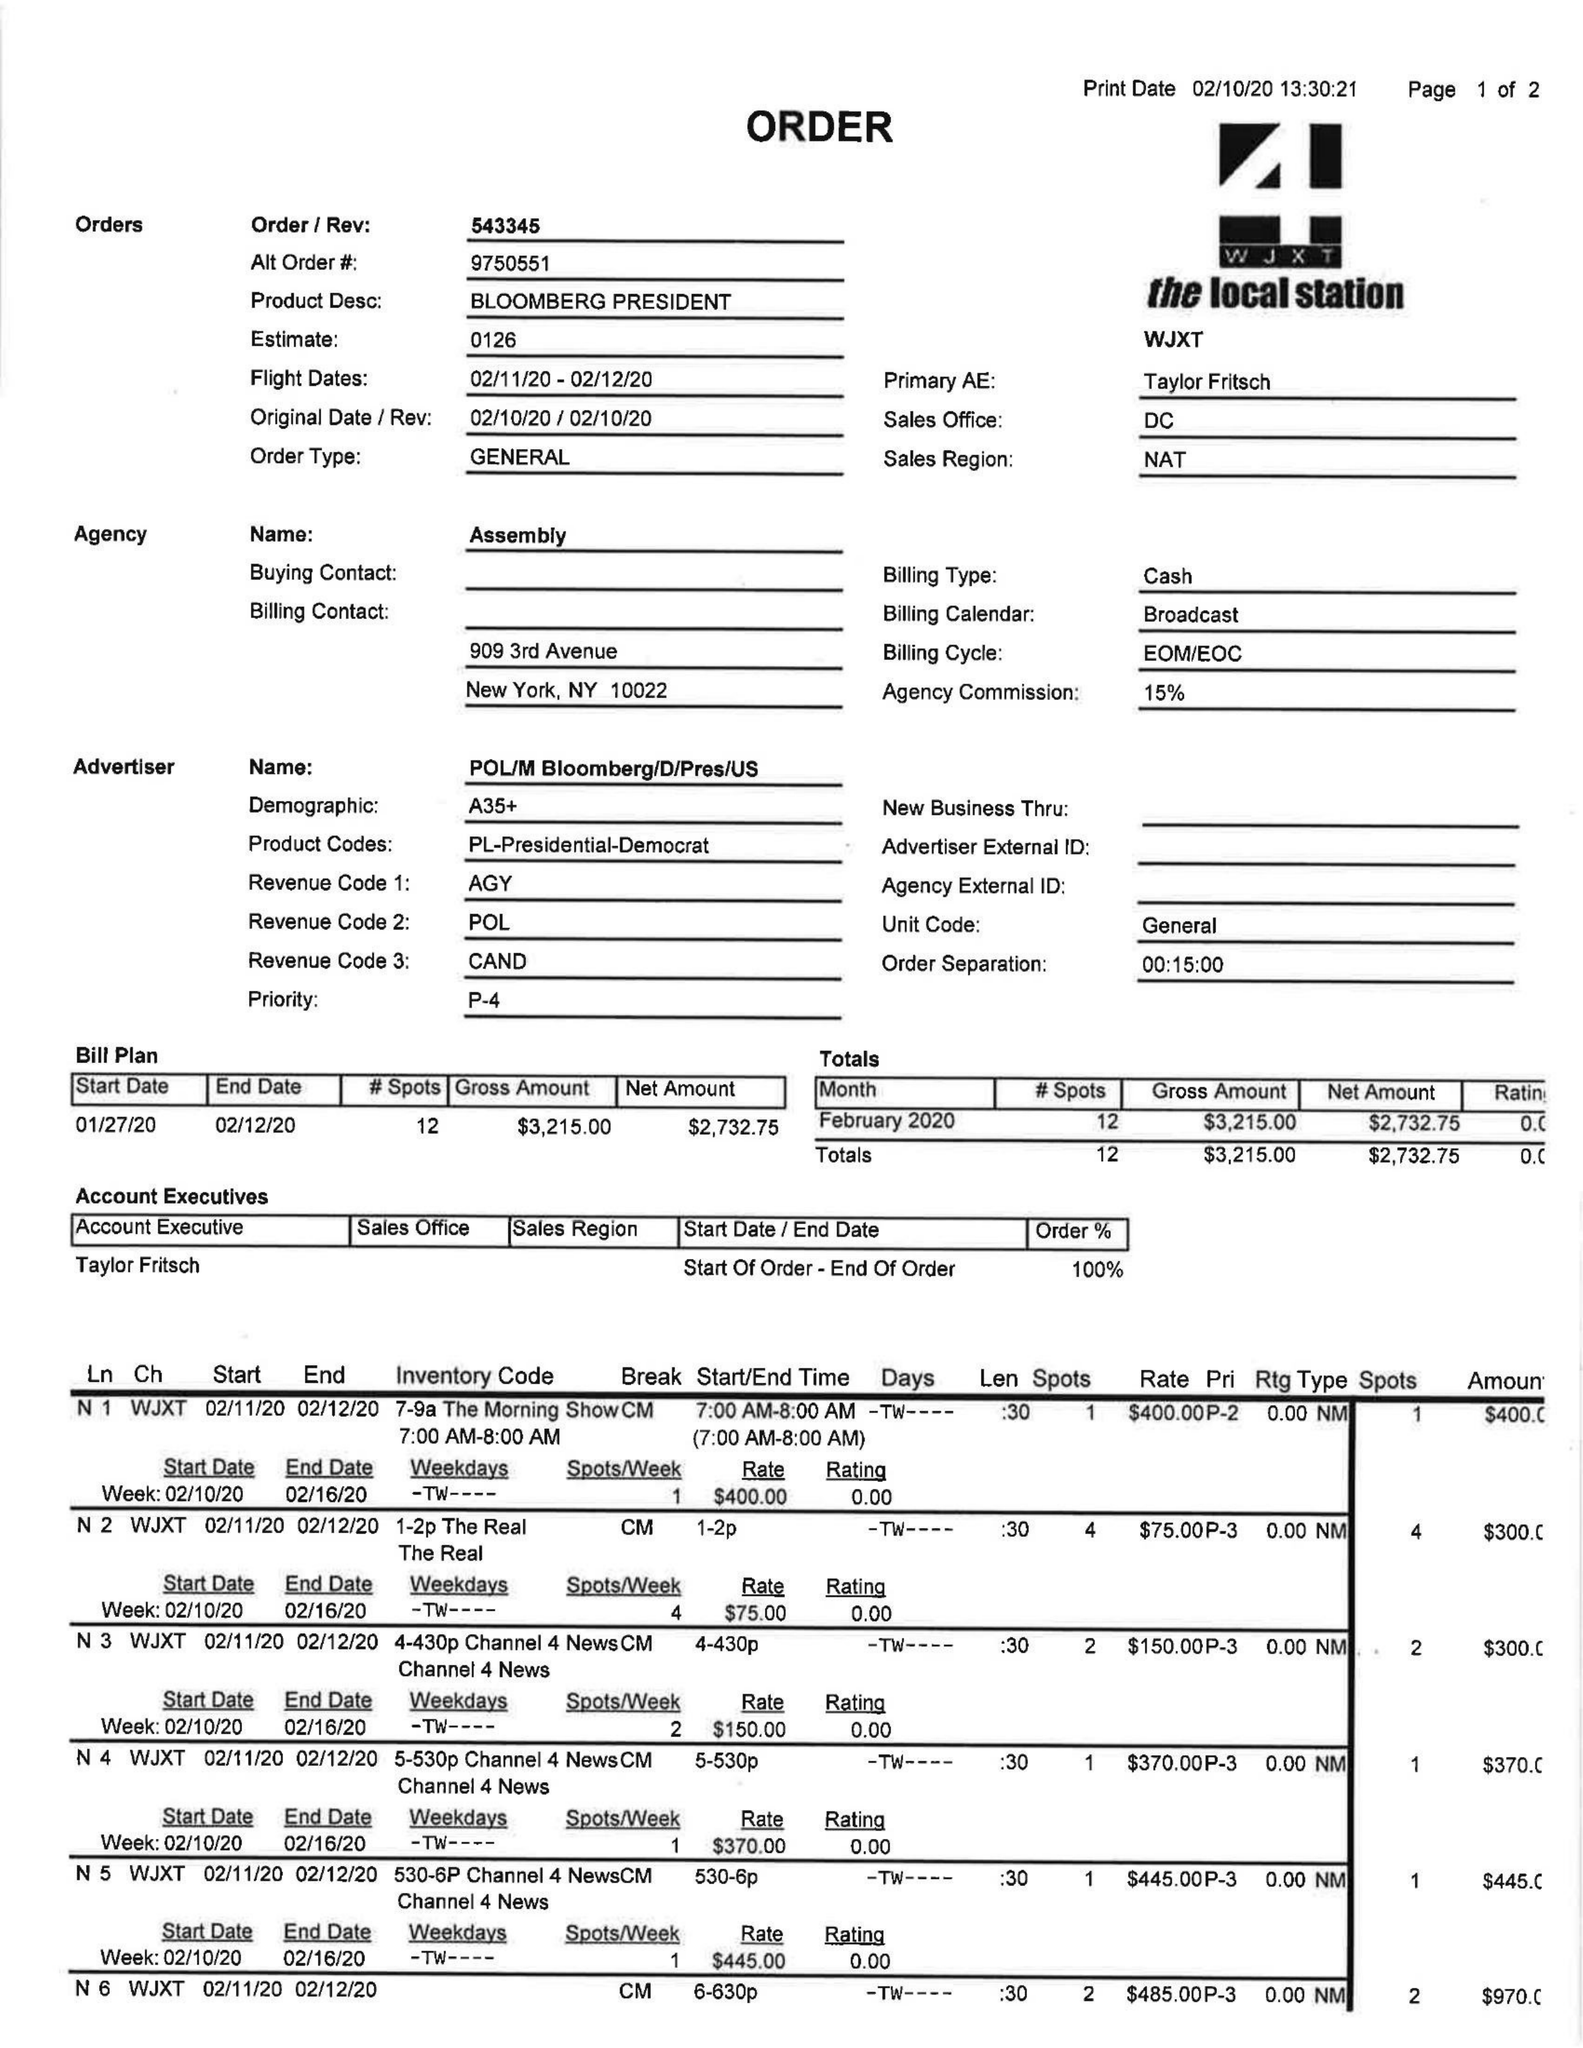What is the value for the flight_to?
Answer the question using a single word or phrase. 02/12/20 